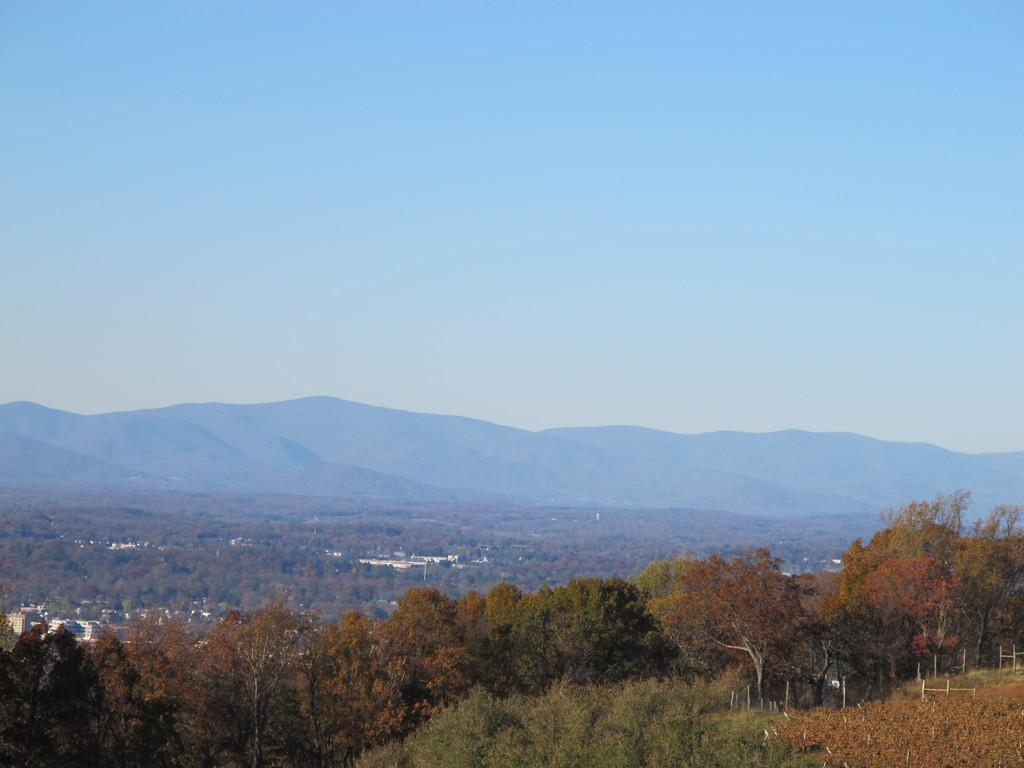What type of terrain is visible in the image? Ground is visible in the image. What structures can be seen in the image? There are poles in the image. What type of vegetation is present in the image? There are green and orange trees in the image. What can be seen in the background of the image? Trees, buildings, mountains, and the sky are visible in the background of the image. What industry is being represented by the riddle in the image? There is no riddle or industry present in the image. What type of punishment is being depicted in the image? There is no punishment being depicted in the image. 